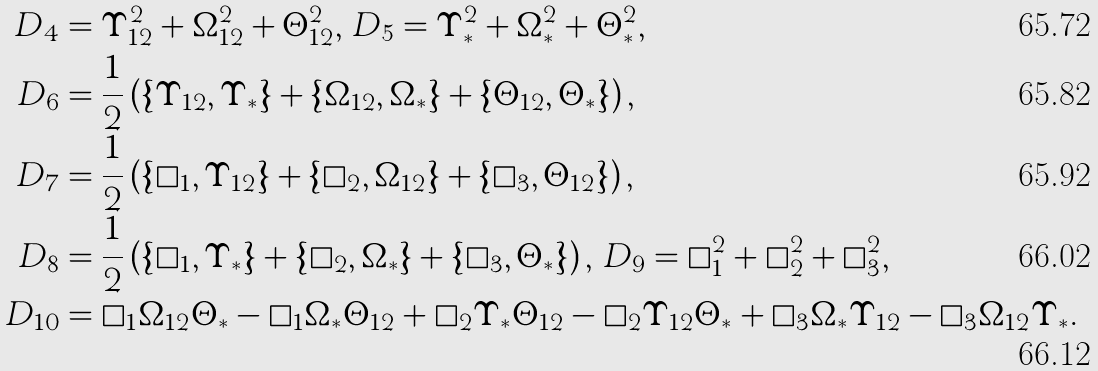<formula> <loc_0><loc_0><loc_500><loc_500>D _ { 4 } & = \Upsilon _ { 1 2 } ^ { 2 } + \Omega _ { 1 2 } ^ { 2 } + \Theta _ { 1 2 } ^ { 2 } , \, D _ { 5 } = \Upsilon _ { * } ^ { 2 } + \Omega _ { * } ^ { 2 } + \Theta _ { * } ^ { 2 } , \\ D _ { 6 } & = \frac { 1 } { 2 } \left ( \{ \Upsilon _ { 1 2 } , \Upsilon _ { * } \} + \{ \Omega _ { 1 2 } , \Omega _ { * } \} + \{ \Theta _ { 1 2 } , \Theta _ { * } \} \right ) , \\ D _ { 7 } & = \frac { 1 } { 2 } \left ( \{ \square _ { 1 } , \Upsilon _ { 1 2 } \} + \{ \square _ { 2 } , \Omega _ { 1 2 } \} + \{ \square _ { 3 } , \Theta _ { 1 2 } \} \right ) , \\ D _ { 8 } & = \frac { 1 } { 2 } \left ( \{ \square _ { 1 } , \Upsilon _ { * } \} + \{ \square _ { 2 } , \Omega _ { * } \} + \{ \square _ { 3 } , \Theta _ { * } \} \right ) , \, D _ { 9 } = \square _ { 1 } ^ { 2 } + \square _ { 2 } ^ { 2 } + \square _ { 3 } ^ { 2 } , \\ D _ { 1 0 } & = \square _ { 1 } \Omega _ { 1 2 } \Theta _ { * } - \square _ { 1 } \Omega _ { * } \Theta _ { 1 2 } + \square _ { 2 } \Upsilon _ { * } \Theta _ { 1 2 } - \square _ { 2 } \Upsilon _ { 1 2 } \Theta _ { * } + \square _ { 3 } \Omega _ { * } \Upsilon _ { 1 2 } - \square _ { 3 } \Omega _ { 1 2 } \Upsilon _ { * } .</formula> 